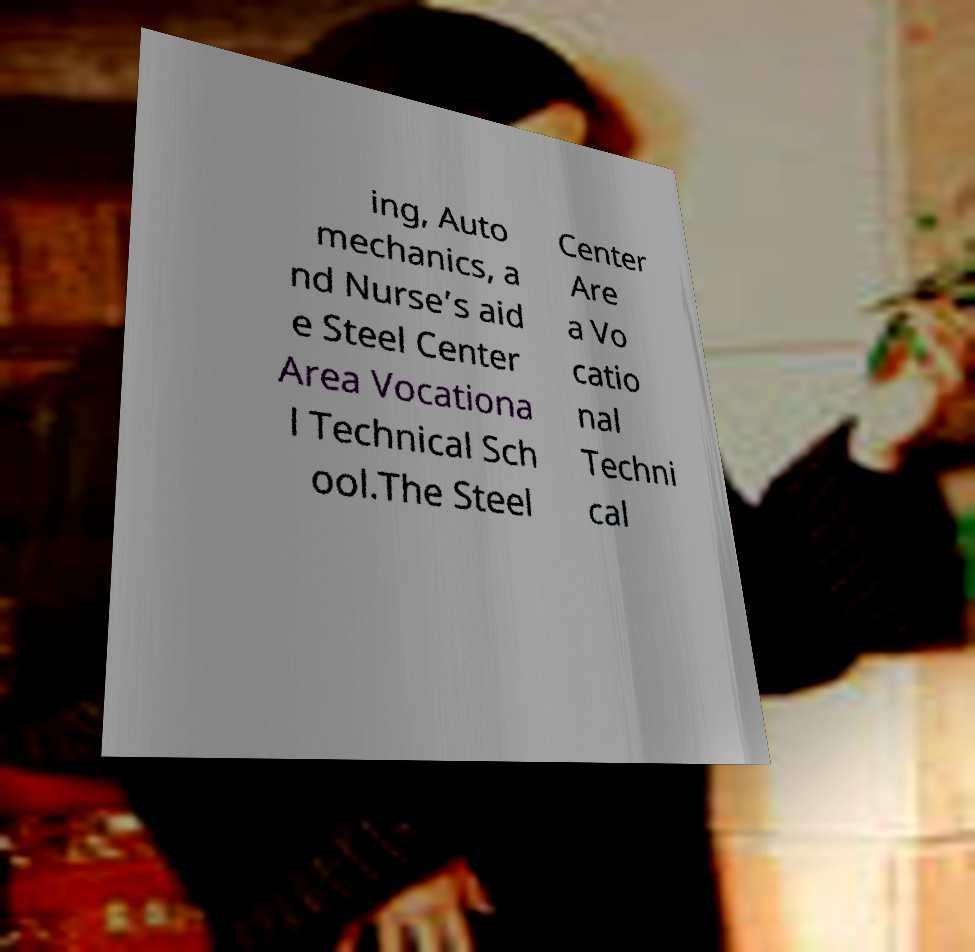Can you read and provide the text displayed in the image?This photo seems to have some interesting text. Can you extract and type it out for me? ing, Auto mechanics, a nd Nurse’s aid e Steel Center Area Vocationa l Technical Sch ool.The Steel Center Are a Vo catio nal Techni cal 